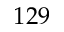<formula> <loc_0><loc_0><loc_500><loc_500>1 2 9</formula> 